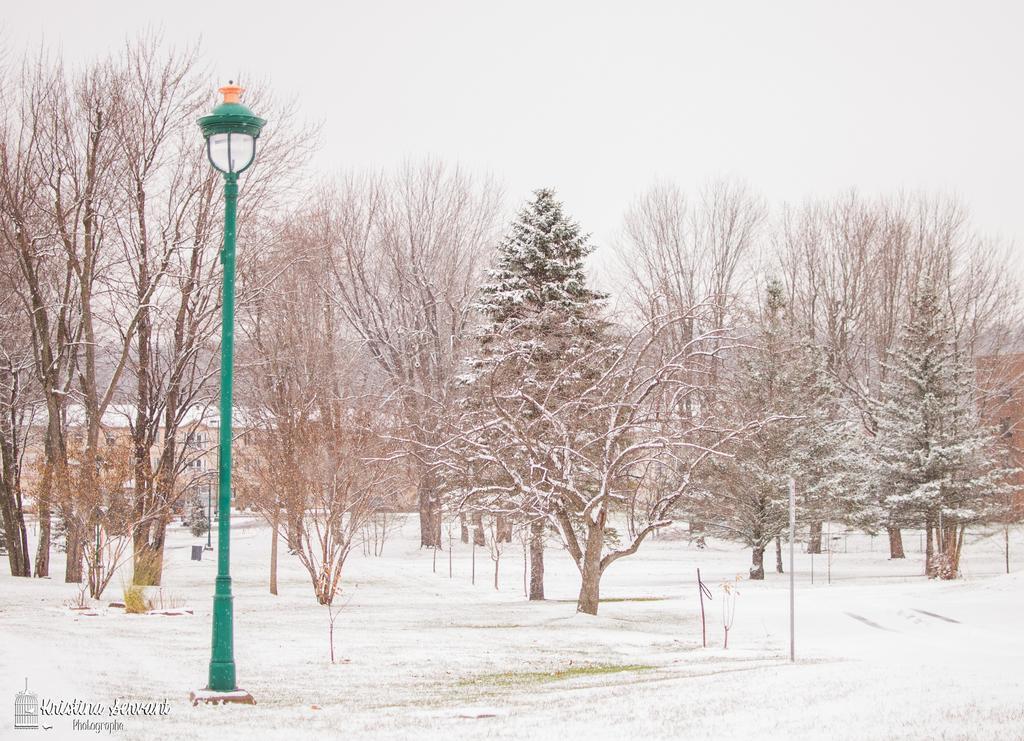In one or two sentences, can you explain what this image depicts? In the picture we can see a snow surface on it we can see a pole with lamp and besides we can see trees and snow on it. 